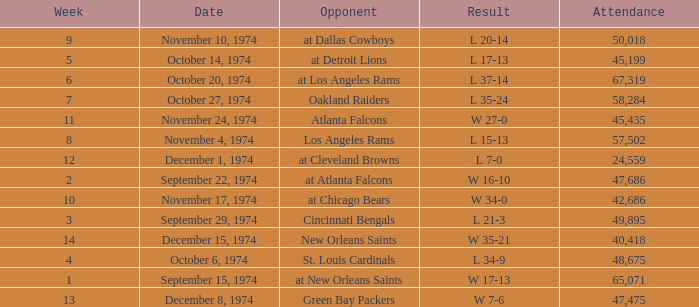Which week was the game played on December 8, 1974? 13.0. 